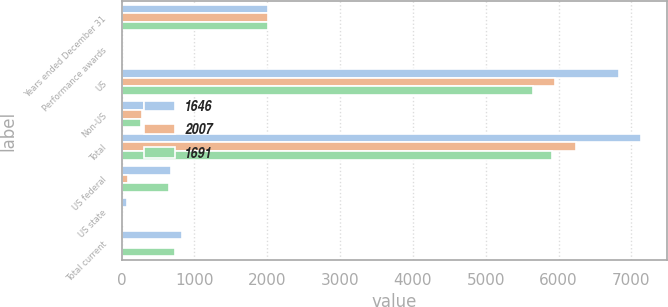Convert chart to OTSL. <chart><loc_0><loc_0><loc_500><loc_500><stacked_bar_chart><ecel><fcel>Years ended December 31<fcel>Performance awards<fcel>US<fcel>Non-US<fcel>Total<fcel>US federal<fcel>US state<fcel>Total current<nl><fcel>1646<fcel>2014<fcel>5.1<fcel>6829<fcel>308<fcel>7137<fcel>676<fcel>69<fcel>836<nl><fcel>2007<fcel>2013<fcel>4.2<fcel>5946<fcel>286<fcel>6232<fcel>82<fcel>11<fcel>5<nl><fcel>1691<fcel>2012<fcel>4.9<fcel>5647<fcel>263<fcel>5910<fcel>657<fcel>19<fcel>728<nl></chart> 